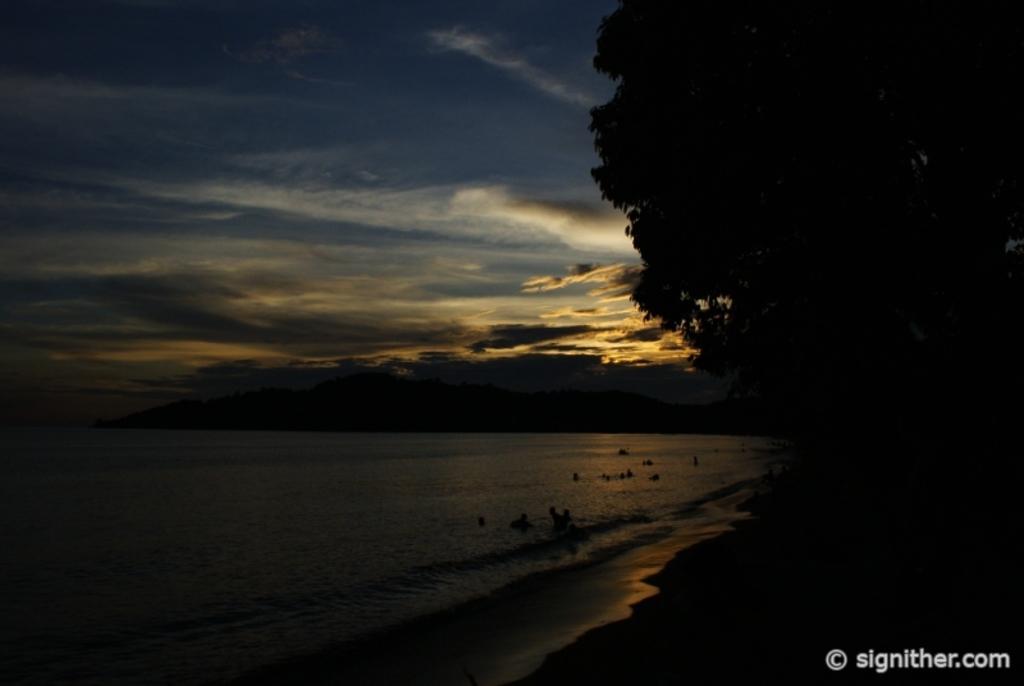Could you give a brief overview of what you see in this image? In this image we can see a few people in the water, there are some trees and mountains, in the background we can see the sky with cloud. 